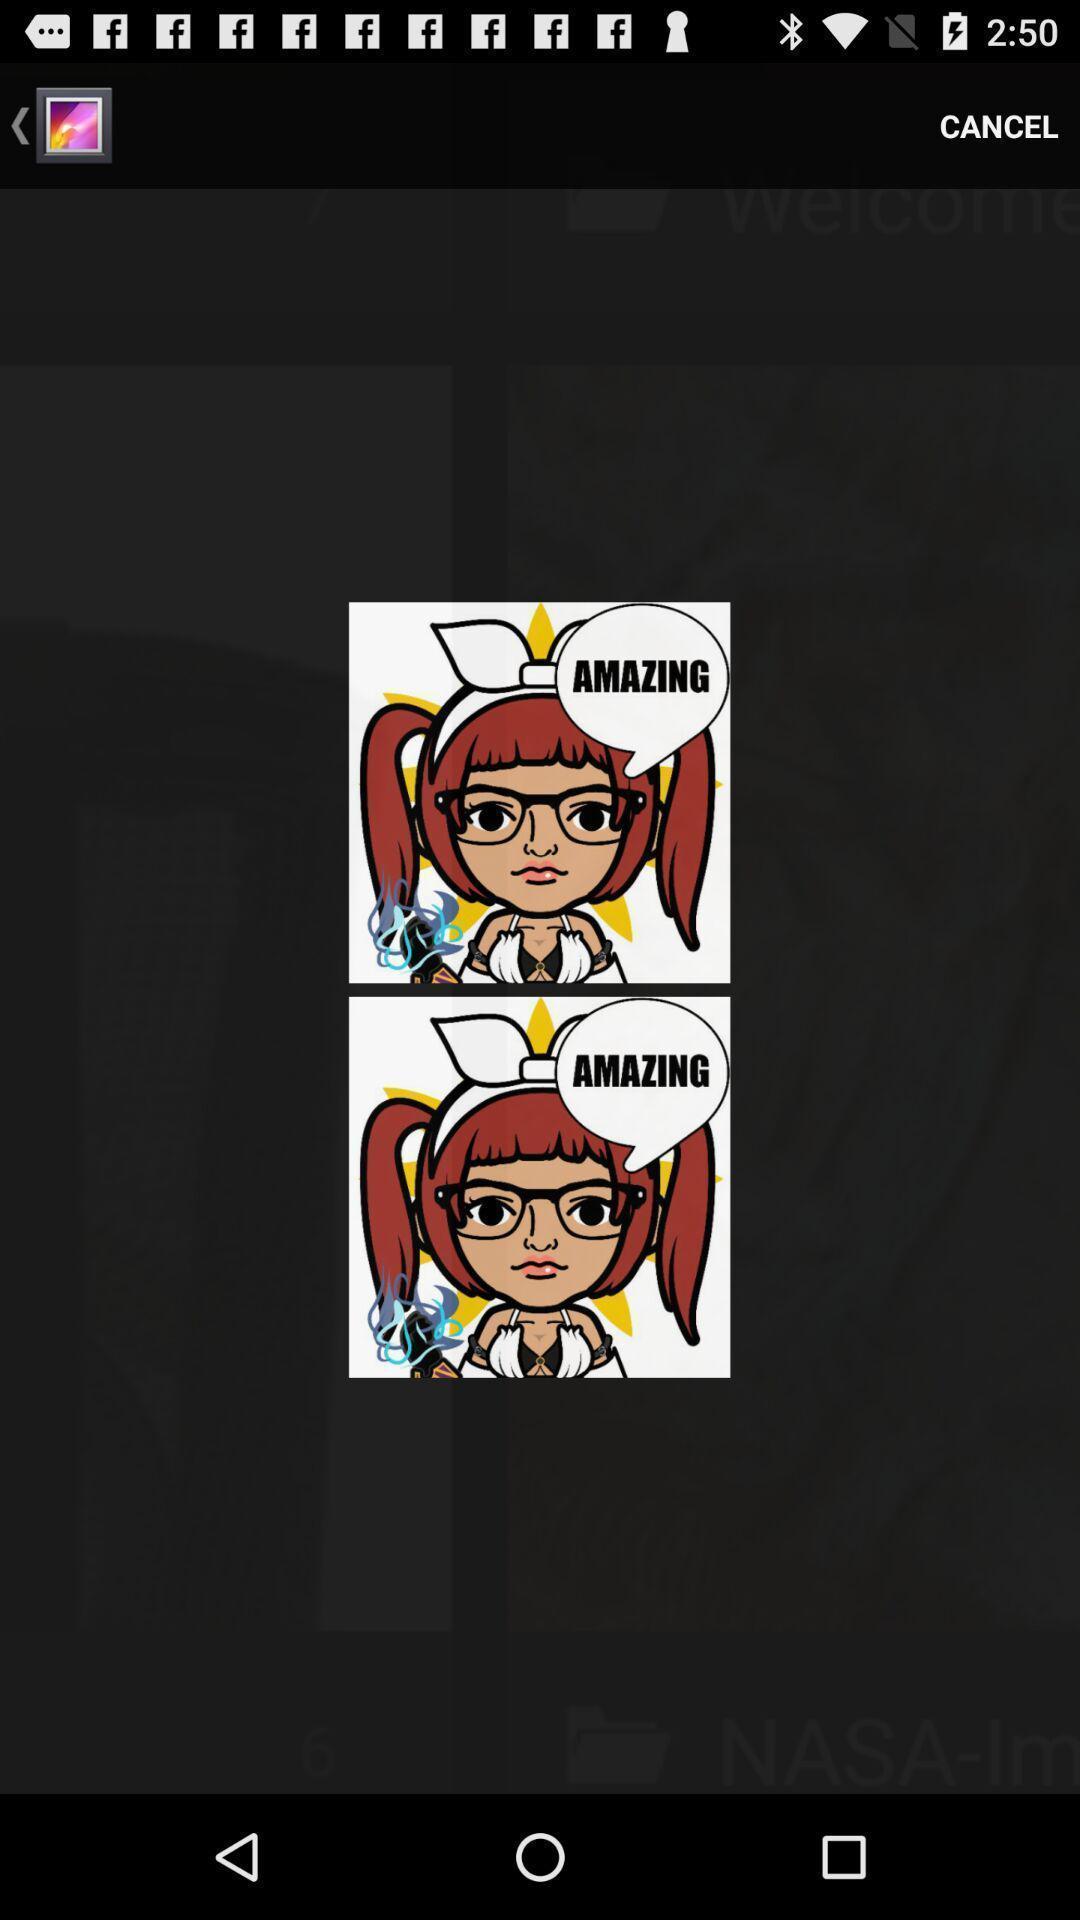Describe the content in this image. Screen showing image. 